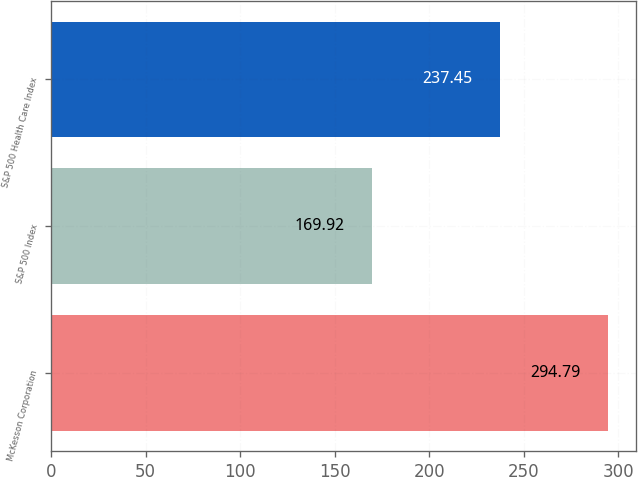<chart> <loc_0><loc_0><loc_500><loc_500><bar_chart><fcel>McKesson Corporation<fcel>S&P 500 Index<fcel>S&P 500 Health Care Index<nl><fcel>294.79<fcel>169.92<fcel>237.45<nl></chart> 